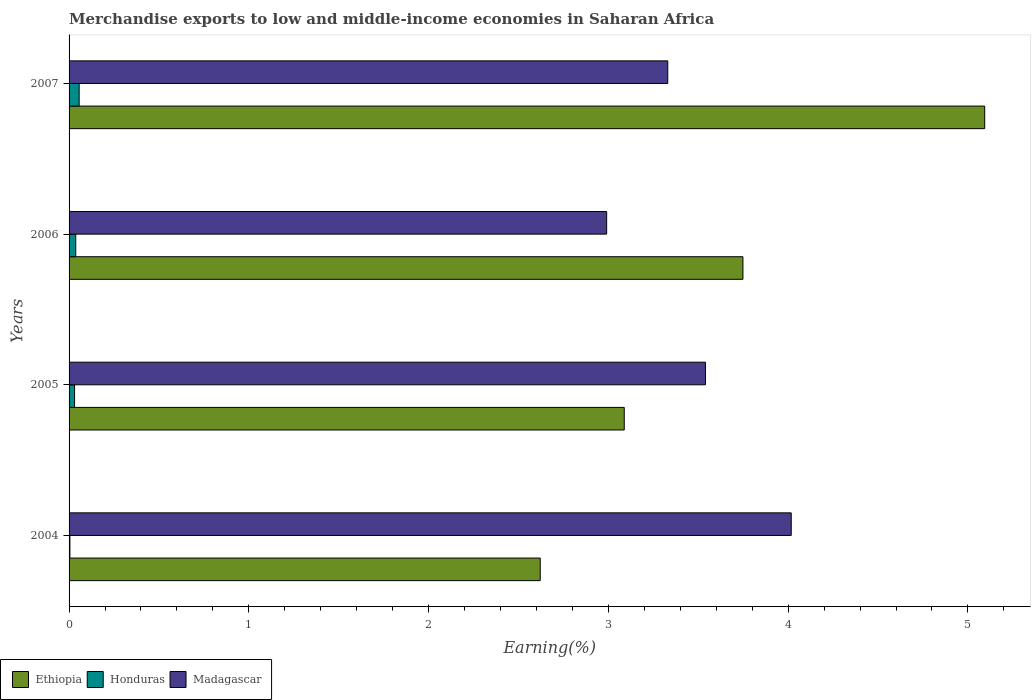Are the number of bars on each tick of the Y-axis equal?
Give a very brief answer. Yes. In how many cases, is the number of bars for a given year not equal to the number of legend labels?
Ensure brevity in your answer.  0. What is the percentage of amount earned from merchandise exports in Honduras in 2005?
Your answer should be compact. 0.03. Across all years, what is the maximum percentage of amount earned from merchandise exports in Honduras?
Keep it short and to the point. 0.06. Across all years, what is the minimum percentage of amount earned from merchandise exports in Madagascar?
Give a very brief answer. 2.99. What is the total percentage of amount earned from merchandise exports in Honduras in the graph?
Your response must be concise. 0.13. What is the difference between the percentage of amount earned from merchandise exports in Madagascar in 2004 and that in 2006?
Provide a succinct answer. 1.03. What is the difference between the percentage of amount earned from merchandise exports in Ethiopia in 2006 and the percentage of amount earned from merchandise exports in Madagascar in 2005?
Offer a terse response. 0.21. What is the average percentage of amount earned from merchandise exports in Honduras per year?
Provide a short and direct response. 0.03. In the year 2005, what is the difference between the percentage of amount earned from merchandise exports in Madagascar and percentage of amount earned from merchandise exports in Ethiopia?
Keep it short and to the point. 0.45. What is the ratio of the percentage of amount earned from merchandise exports in Honduras in 2004 to that in 2007?
Provide a short and direct response. 0.08. Is the percentage of amount earned from merchandise exports in Madagascar in 2004 less than that in 2005?
Your response must be concise. No. Is the difference between the percentage of amount earned from merchandise exports in Madagascar in 2004 and 2006 greater than the difference between the percentage of amount earned from merchandise exports in Ethiopia in 2004 and 2006?
Your answer should be very brief. Yes. What is the difference between the highest and the second highest percentage of amount earned from merchandise exports in Honduras?
Give a very brief answer. 0.02. What is the difference between the highest and the lowest percentage of amount earned from merchandise exports in Ethiopia?
Give a very brief answer. 2.47. In how many years, is the percentage of amount earned from merchandise exports in Madagascar greater than the average percentage of amount earned from merchandise exports in Madagascar taken over all years?
Offer a very short reply. 2. What does the 3rd bar from the top in 2004 represents?
Your answer should be very brief. Ethiopia. What does the 1st bar from the bottom in 2006 represents?
Your answer should be compact. Ethiopia. Are all the bars in the graph horizontal?
Provide a succinct answer. Yes. How many years are there in the graph?
Your answer should be compact. 4. What is the difference between two consecutive major ticks on the X-axis?
Give a very brief answer. 1. Does the graph contain any zero values?
Offer a very short reply. No. Does the graph contain grids?
Provide a succinct answer. No. How many legend labels are there?
Your answer should be compact. 3. How are the legend labels stacked?
Make the answer very short. Horizontal. What is the title of the graph?
Your response must be concise. Merchandise exports to low and middle-income economies in Saharan Africa. Does "Panama" appear as one of the legend labels in the graph?
Give a very brief answer. No. What is the label or title of the X-axis?
Ensure brevity in your answer.  Earning(%). What is the label or title of the Y-axis?
Ensure brevity in your answer.  Years. What is the Earning(%) in Ethiopia in 2004?
Offer a terse response. 2.62. What is the Earning(%) of Honduras in 2004?
Offer a very short reply. 0. What is the Earning(%) in Madagascar in 2004?
Keep it short and to the point. 4.02. What is the Earning(%) in Ethiopia in 2005?
Give a very brief answer. 3.09. What is the Earning(%) in Honduras in 2005?
Provide a succinct answer. 0.03. What is the Earning(%) in Madagascar in 2005?
Provide a short and direct response. 3.54. What is the Earning(%) in Ethiopia in 2006?
Offer a terse response. 3.75. What is the Earning(%) in Honduras in 2006?
Your answer should be very brief. 0.04. What is the Earning(%) in Madagascar in 2006?
Your response must be concise. 2.99. What is the Earning(%) of Ethiopia in 2007?
Make the answer very short. 5.09. What is the Earning(%) of Honduras in 2007?
Ensure brevity in your answer.  0.06. What is the Earning(%) in Madagascar in 2007?
Provide a succinct answer. 3.33. Across all years, what is the maximum Earning(%) in Ethiopia?
Ensure brevity in your answer.  5.09. Across all years, what is the maximum Earning(%) of Honduras?
Ensure brevity in your answer.  0.06. Across all years, what is the maximum Earning(%) of Madagascar?
Give a very brief answer. 4.02. Across all years, what is the minimum Earning(%) in Ethiopia?
Ensure brevity in your answer.  2.62. Across all years, what is the minimum Earning(%) of Honduras?
Keep it short and to the point. 0. Across all years, what is the minimum Earning(%) of Madagascar?
Provide a succinct answer. 2.99. What is the total Earning(%) of Ethiopia in the graph?
Your answer should be very brief. 14.55. What is the total Earning(%) in Honduras in the graph?
Make the answer very short. 0.13. What is the total Earning(%) in Madagascar in the graph?
Give a very brief answer. 13.88. What is the difference between the Earning(%) of Ethiopia in 2004 and that in 2005?
Give a very brief answer. -0.47. What is the difference between the Earning(%) of Honduras in 2004 and that in 2005?
Your response must be concise. -0.03. What is the difference between the Earning(%) of Madagascar in 2004 and that in 2005?
Your response must be concise. 0.48. What is the difference between the Earning(%) of Ethiopia in 2004 and that in 2006?
Your response must be concise. -1.13. What is the difference between the Earning(%) of Honduras in 2004 and that in 2006?
Your answer should be very brief. -0.03. What is the difference between the Earning(%) of Madagascar in 2004 and that in 2006?
Keep it short and to the point. 1.03. What is the difference between the Earning(%) of Ethiopia in 2004 and that in 2007?
Your answer should be very brief. -2.47. What is the difference between the Earning(%) of Honduras in 2004 and that in 2007?
Your answer should be very brief. -0.05. What is the difference between the Earning(%) of Madagascar in 2004 and that in 2007?
Your answer should be compact. 0.69. What is the difference between the Earning(%) in Ethiopia in 2005 and that in 2006?
Make the answer very short. -0.66. What is the difference between the Earning(%) of Honduras in 2005 and that in 2006?
Your response must be concise. -0.01. What is the difference between the Earning(%) of Madagascar in 2005 and that in 2006?
Provide a succinct answer. 0.55. What is the difference between the Earning(%) of Ethiopia in 2005 and that in 2007?
Provide a short and direct response. -2.01. What is the difference between the Earning(%) in Honduras in 2005 and that in 2007?
Your response must be concise. -0.03. What is the difference between the Earning(%) in Madagascar in 2005 and that in 2007?
Your response must be concise. 0.21. What is the difference between the Earning(%) in Ethiopia in 2006 and that in 2007?
Give a very brief answer. -1.34. What is the difference between the Earning(%) of Honduras in 2006 and that in 2007?
Your response must be concise. -0.02. What is the difference between the Earning(%) of Madagascar in 2006 and that in 2007?
Your response must be concise. -0.34. What is the difference between the Earning(%) of Ethiopia in 2004 and the Earning(%) of Honduras in 2005?
Offer a very short reply. 2.59. What is the difference between the Earning(%) of Ethiopia in 2004 and the Earning(%) of Madagascar in 2005?
Offer a terse response. -0.92. What is the difference between the Earning(%) in Honduras in 2004 and the Earning(%) in Madagascar in 2005?
Offer a terse response. -3.54. What is the difference between the Earning(%) in Ethiopia in 2004 and the Earning(%) in Honduras in 2006?
Provide a short and direct response. 2.58. What is the difference between the Earning(%) of Ethiopia in 2004 and the Earning(%) of Madagascar in 2006?
Provide a succinct answer. -0.37. What is the difference between the Earning(%) in Honduras in 2004 and the Earning(%) in Madagascar in 2006?
Your answer should be compact. -2.99. What is the difference between the Earning(%) in Ethiopia in 2004 and the Earning(%) in Honduras in 2007?
Provide a succinct answer. 2.56. What is the difference between the Earning(%) of Ethiopia in 2004 and the Earning(%) of Madagascar in 2007?
Your answer should be very brief. -0.71. What is the difference between the Earning(%) of Honduras in 2004 and the Earning(%) of Madagascar in 2007?
Offer a terse response. -3.33. What is the difference between the Earning(%) of Ethiopia in 2005 and the Earning(%) of Honduras in 2006?
Your answer should be very brief. 3.05. What is the difference between the Earning(%) of Ethiopia in 2005 and the Earning(%) of Madagascar in 2006?
Offer a terse response. 0.1. What is the difference between the Earning(%) of Honduras in 2005 and the Earning(%) of Madagascar in 2006?
Your answer should be compact. -2.96. What is the difference between the Earning(%) in Ethiopia in 2005 and the Earning(%) in Honduras in 2007?
Provide a succinct answer. 3.03. What is the difference between the Earning(%) of Ethiopia in 2005 and the Earning(%) of Madagascar in 2007?
Your answer should be compact. -0.24. What is the difference between the Earning(%) of Honduras in 2005 and the Earning(%) of Madagascar in 2007?
Your answer should be very brief. -3.3. What is the difference between the Earning(%) of Ethiopia in 2006 and the Earning(%) of Honduras in 2007?
Provide a succinct answer. 3.69. What is the difference between the Earning(%) of Ethiopia in 2006 and the Earning(%) of Madagascar in 2007?
Your answer should be compact. 0.42. What is the difference between the Earning(%) of Honduras in 2006 and the Earning(%) of Madagascar in 2007?
Give a very brief answer. -3.29. What is the average Earning(%) of Ethiopia per year?
Your response must be concise. 3.64. What is the average Earning(%) of Honduras per year?
Provide a succinct answer. 0.03. What is the average Earning(%) in Madagascar per year?
Give a very brief answer. 3.47. In the year 2004, what is the difference between the Earning(%) of Ethiopia and Earning(%) of Honduras?
Ensure brevity in your answer.  2.62. In the year 2004, what is the difference between the Earning(%) of Ethiopia and Earning(%) of Madagascar?
Offer a terse response. -1.4. In the year 2004, what is the difference between the Earning(%) in Honduras and Earning(%) in Madagascar?
Provide a succinct answer. -4.01. In the year 2005, what is the difference between the Earning(%) of Ethiopia and Earning(%) of Honduras?
Provide a short and direct response. 3.06. In the year 2005, what is the difference between the Earning(%) of Ethiopia and Earning(%) of Madagascar?
Provide a succinct answer. -0.45. In the year 2005, what is the difference between the Earning(%) of Honduras and Earning(%) of Madagascar?
Provide a short and direct response. -3.51. In the year 2006, what is the difference between the Earning(%) of Ethiopia and Earning(%) of Honduras?
Your response must be concise. 3.71. In the year 2006, what is the difference between the Earning(%) of Ethiopia and Earning(%) of Madagascar?
Give a very brief answer. 0.76. In the year 2006, what is the difference between the Earning(%) in Honduras and Earning(%) in Madagascar?
Make the answer very short. -2.95. In the year 2007, what is the difference between the Earning(%) in Ethiopia and Earning(%) in Honduras?
Offer a terse response. 5.04. In the year 2007, what is the difference between the Earning(%) of Ethiopia and Earning(%) of Madagascar?
Your response must be concise. 1.76. In the year 2007, what is the difference between the Earning(%) of Honduras and Earning(%) of Madagascar?
Offer a very short reply. -3.27. What is the ratio of the Earning(%) of Ethiopia in 2004 to that in 2005?
Offer a terse response. 0.85. What is the ratio of the Earning(%) in Honduras in 2004 to that in 2005?
Your answer should be very brief. 0.15. What is the ratio of the Earning(%) in Madagascar in 2004 to that in 2005?
Your response must be concise. 1.13. What is the ratio of the Earning(%) of Ethiopia in 2004 to that in 2006?
Your response must be concise. 0.7. What is the ratio of the Earning(%) of Honduras in 2004 to that in 2006?
Provide a succinct answer. 0.12. What is the ratio of the Earning(%) of Madagascar in 2004 to that in 2006?
Ensure brevity in your answer.  1.34. What is the ratio of the Earning(%) of Ethiopia in 2004 to that in 2007?
Give a very brief answer. 0.51. What is the ratio of the Earning(%) of Honduras in 2004 to that in 2007?
Your answer should be very brief. 0.08. What is the ratio of the Earning(%) in Madagascar in 2004 to that in 2007?
Make the answer very short. 1.21. What is the ratio of the Earning(%) of Ethiopia in 2005 to that in 2006?
Your answer should be very brief. 0.82. What is the ratio of the Earning(%) in Honduras in 2005 to that in 2006?
Ensure brevity in your answer.  0.82. What is the ratio of the Earning(%) of Madagascar in 2005 to that in 2006?
Give a very brief answer. 1.18. What is the ratio of the Earning(%) in Ethiopia in 2005 to that in 2007?
Offer a very short reply. 0.61. What is the ratio of the Earning(%) of Honduras in 2005 to that in 2007?
Provide a short and direct response. 0.55. What is the ratio of the Earning(%) in Madagascar in 2005 to that in 2007?
Offer a very short reply. 1.06. What is the ratio of the Earning(%) in Ethiopia in 2006 to that in 2007?
Make the answer very short. 0.74. What is the ratio of the Earning(%) in Honduras in 2006 to that in 2007?
Your response must be concise. 0.66. What is the ratio of the Earning(%) in Madagascar in 2006 to that in 2007?
Make the answer very short. 0.9. What is the difference between the highest and the second highest Earning(%) in Ethiopia?
Provide a short and direct response. 1.34. What is the difference between the highest and the second highest Earning(%) in Honduras?
Keep it short and to the point. 0.02. What is the difference between the highest and the second highest Earning(%) of Madagascar?
Offer a terse response. 0.48. What is the difference between the highest and the lowest Earning(%) of Ethiopia?
Your answer should be compact. 2.47. What is the difference between the highest and the lowest Earning(%) in Honduras?
Your answer should be compact. 0.05. What is the difference between the highest and the lowest Earning(%) of Madagascar?
Provide a succinct answer. 1.03. 